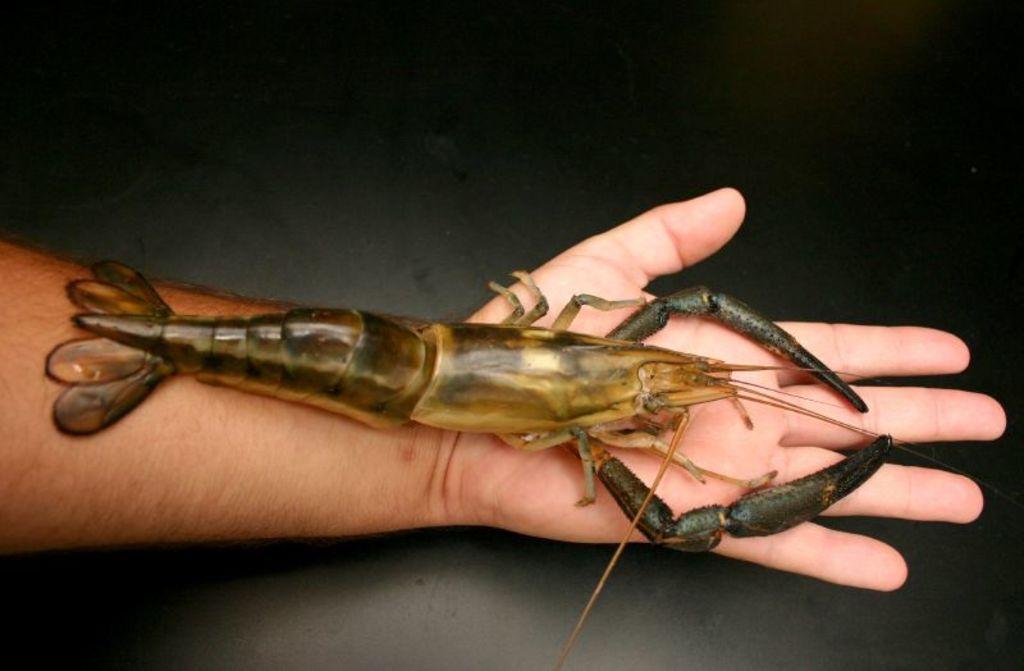Please provide a concise description of this image. In the center of the picture there is a person holding a shrimp. In the background it is floor. 